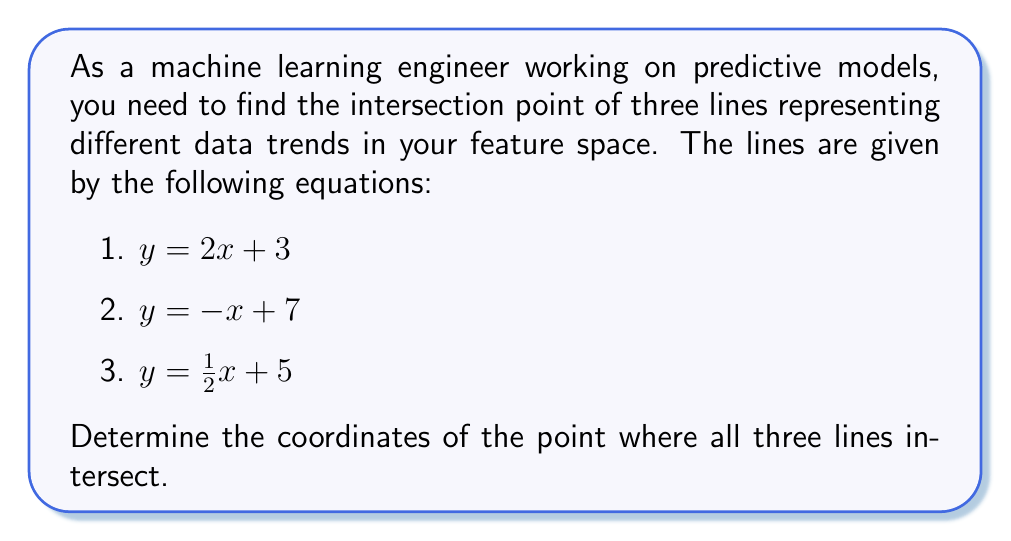Solve this math problem. To find the intersection point of these three lines, we need to solve the system of equations:

1. $y = 2x + 3$
2. $y = -x + 7$
3. $y = \frac{1}{2}x + 5$

Step 1: Equate equations 1 and 2:
$2x + 3 = -x + 7$
$3x = 4$
$x = \frac{4}{3}$

Step 2: Substitute $x = \frac{4}{3}$ into equation 1:
$y = 2(\frac{4}{3}) + 3$
$y = \frac{8}{3} + 3$
$y = \frac{8}{3} + \frac{9}{3} = \frac{17}{3}$

Step 3: Verify that the point $(\frac{4}{3}, \frac{17}{3})$ satisfies equation 3:
$\frac{17}{3} = \frac{1}{2}(\frac{4}{3}) + 5$
$\frac{17}{3} = \frac{2}{3} + 5 = \frac{2}{3} + \frac{15}{3} = \frac{17}{3}$

The equality holds, confirming that this point satisfies all three equations.

[asy]
import geometry;

size(200);
real xmin = -1, xmax = 4, ymin = 0, ymax = 8;
draw((xmin,0)--(xmax,0), arrow=Arrow(TeXHead));
draw((0,ymin)--(0,ymax), arrow=Arrow(TeXHead));

real f1(real x) { return 2x + 3; }
real f2(real x) { return -x + 7; }
real f3(real x) { return 0.5x + 5; }

draw(graph(f1, xmin, xmax), blue);
draw(graph(f2, xmin, xmax), red);
draw(graph(f3, xmin, xmax), green);

dot((4/3, 17/3), linewidth(4));
label("(4/3, 17/3)", (4/3, 17/3), NE);

[/asy]
Answer: $(\frac{4}{3}, \frac{17}{3})$ 